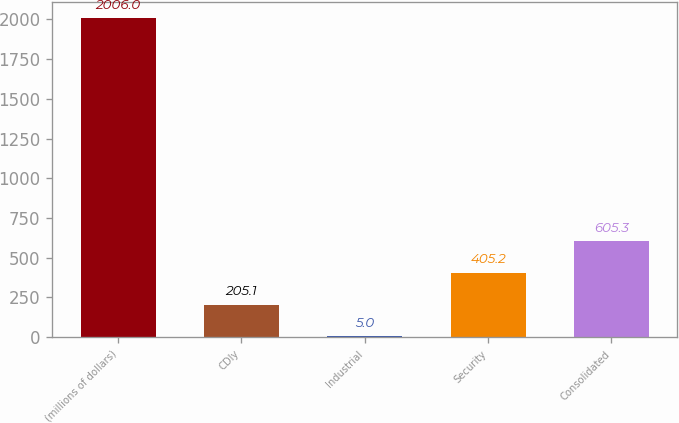Convert chart. <chart><loc_0><loc_0><loc_500><loc_500><bar_chart><fcel>(millions of dollars)<fcel>CDIy<fcel>Industrial<fcel>Security<fcel>Consolidated<nl><fcel>2006<fcel>205.1<fcel>5<fcel>405.2<fcel>605.3<nl></chart> 